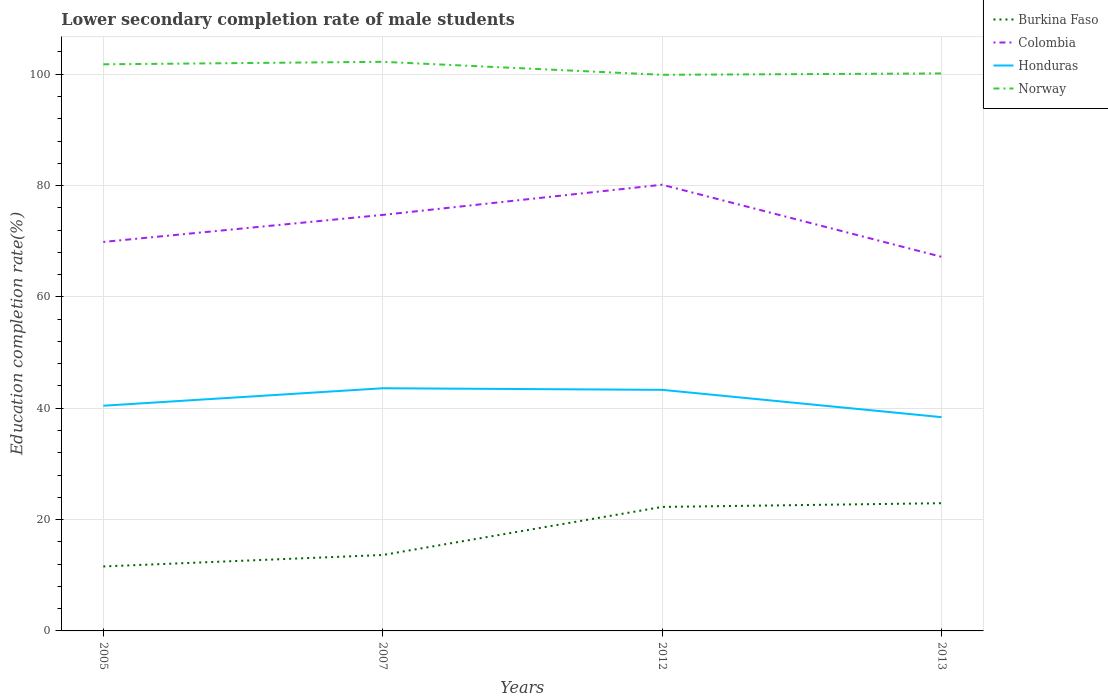Is the number of lines equal to the number of legend labels?
Offer a very short reply. Yes. Across all years, what is the maximum lower secondary completion rate of male students in Honduras?
Give a very brief answer. 38.4. What is the total lower secondary completion rate of male students in Burkina Faso in the graph?
Provide a short and direct response. -11.36. What is the difference between the highest and the second highest lower secondary completion rate of male students in Colombia?
Provide a succinct answer. 12.95. Are the values on the major ticks of Y-axis written in scientific E-notation?
Make the answer very short. No. Does the graph contain any zero values?
Ensure brevity in your answer.  No. Does the graph contain grids?
Your response must be concise. Yes. How many legend labels are there?
Give a very brief answer. 4. How are the legend labels stacked?
Your response must be concise. Vertical. What is the title of the graph?
Provide a succinct answer. Lower secondary completion rate of male students. What is the label or title of the X-axis?
Your response must be concise. Years. What is the label or title of the Y-axis?
Provide a succinct answer. Education completion rate(%). What is the Education completion rate(%) in Burkina Faso in 2005?
Make the answer very short. 11.58. What is the Education completion rate(%) in Colombia in 2005?
Give a very brief answer. 69.87. What is the Education completion rate(%) of Honduras in 2005?
Keep it short and to the point. 40.45. What is the Education completion rate(%) in Norway in 2005?
Your response must be concise. 101.78. What is the Education completion rate(%) of Burkina Faso in 2007?
Keep it short and to the point. 13.64. What is the Education completion rate(%) of Colombia in 2007?
Make the answer very short. 74.73. What is the Education completion rate(%) of Honduras in 2007?
Give a very brief answer. 43.59. What is the Education completion rate(%) in Norway in 2007?
Give a very brief answer. 102.23. What is the Education completion rate(%) in Burkina Faso in 2012?
Offer a very short reply. 22.27. What is the Education completion rate(%) in Colombia in 2012?
Keep it short and to the point. 80.15. What is the Education completion rate(%) of Honduras in 2012?
Keep it short and to the point. 43.3. What is the Education completion rate(%) of Norway in 2012?
Provide a short and direct response. 99.89. What is the Education completion rate(%) of Burkina Faso in 2013?
Keep it short and to the point. 22.94. What is the Education completion rate(%) of Colombia in 2013?
Offer a terse response. 67.2. What is the Education completion rate(%) in Honduras in 2013?
Offer a terse response. 38.4. What is the Education completion rate(%) in Norway in 2013?
Offer a terse response. 100.14. Across all years, what is the maximum Education completion rate(%) in Burkina Faso?
Your answer should be very brief. 22.94. Across all years, what is the maximum Education completion rate(%) of Colombia?
Offer a very short reply. 80.15. Across all years, what is the maximum Education completion rate(%) in Honduras?
Give a very brief answer. 43.59. Across all years, what is the maximum Education completion rate(%) of Norway?
Your answer should be compact. 102.23. Across all years, what is the minimum Education completion rate(%) of Burkina Faso?
Offer a very short reply. 11.58. Across all years, what is the minimum Education completion rate(%) in Colombia?
Offer a terse response. 67.2. Across all years, what is the minimum Education completion rate(%) of Honduras?
Your response must be concise. 38.4. Across all years, what is the minimum Education completion rate(%) of Norway?
Provide a succinct answer. 99.89. What is the total Education completion rate(%) in Burkina Faso in the graph?
Ensure brevity in your answer.  70.43. What is the total Education completion rate(%) in Colombia in the graph?
Your answer should be compact. 291.94. What is the total Education completion rate(%) in Honduras in the graph?
Your answer should be compact. 165.74. What is the total Education completion rate(%) of Norway in the graph?
Your response must be concise. 404.03. What is the difference between the Education completion rate(%) in Burkina Faso in 2005 and that in 2007?
Your answer should be very brief. -2.06. What is the difference between the Education completion rate(%) in Colombia in 2005 and that in 2007?
Keep it short and to the point. -4.85. What is the difference between the Education completion rate(%) of Honduras in 2005 and that in 2007?
Offer a very short reply. -3.14. What is the difference between the Education completion rate(%) of Norway in 2005 and that in 2007?
Your answer should be compact. -0.45. What is the difference between the Education completion rate(%) of Burkina Faso in 2005 and that in 2012?
Keep it short and to the point. -10.69. What is the difference between the Education completion rate(%) of Colombia in 2005 and that in 2012?
Your response must be concise. -10.28. What is the difference between the Education completion rate(%) of Honduras in 2005 and that in 2012?
Your answer should be compact. -2.85. What is the difference between the Education completion rate(%) in Norway in 2005 and that in 2012?
Your answer should be very brief. 1.88. What is the difference between the Education completion rate(%) in Burkina Faso in 2005 and that in 2013?
Keep it short and to the point. -11.36. What is the difference between the Education completion rate(%) of Colombia in 2005 and that in 2013?
Make the answer very short. 2.67. What is the difference between the Education completion rate(%) of Honduras in 2005 and that in 2013?
Offer a terse response. 2.05. What is the difference between the Education completion rate(%) in Norway in 2005 and that in 2013?
Make the answer very short. 1.64. What is the difference between the Education completion rate(%) in Burkina Faso in 2007 and that in 2012?
Give a very brief answer. -8.64. What is the difference between the Education completion rate(%) of Colombia in 2007 and that in 2012?
Give a very brief answer. -5.42. What is the difference between the Education completion rate(%) in Honduras in 2007 and that in 2012?
Ensure brevity in your answer.  0.28. What is the difference between the Education completion rate(%) of Norway in 2007 and that in 2012?
Provide a short and direct response. 2.33. What is the difference between the Education completion rate(%) of Burkina Faso in 2007 and that in 2013?
Make the answer very short. -9.3. What is the difference between the Education completion rate(%) of Colombia in 2007 and that in 2013?
Ensure brevity in your answer.  7.53. What is the difference between the Education completion rate(%) of Honduras in 2007 and that in 2013?
Ensure brevity in your answer.  5.19. What is the difference between the Education completion rate(%) in Norway in 2007 and that in 2013?
Ensure brevity in your answer.  2.09. What is the difference between the Education completion rate(%) in Burkina Faso in 2012 and that in 2013?
Your answer should be compact. -0.67. What is the difference between the Education completion rate(%) of Colombia in 2012 and that in 2013?
Your response must be concise. 12.95. What is the difference between the Education completion rate(%) of Honduras in 2012 and that in 2013?
Offer a very short reply. 4.91. What is the difference between the Education completion rate(%) of Norway in 2012 and that in 2013?
Ensure brevity in your answer.  -0.25. What is the difference between the Education completion rate(%) in Burkina Faso in 2005 and the Education completion rate(%) in Colombia in 2007?
Give a very brief answer. -63.14. What is the difference between the Education completion rate(%) of Burkina Faso in 2005 and the Education completion rate(%) of Honduras in 2007?
Provide a short and direct response. -32.01. What is the difference between the Education completion rate(%) of Burkina Faso in 2005 and the Education completion rate(%) of Norway in 2007?
Provide a short and direct response. -90.65. What is the difference between the Education completion rate(%) in Colombia in 2005 and the Education completion rate(%) in Honduras in 2007?
Your answer should be very brief. 26.28. What is the difference between the Education completion rate(%) in Colombia in 2005 and the Education completion rate(%) in Norway in 2007?
Ensure brevity in your answer.  -32.36. What is the difference between the Education completion rate(%) in Honduras in 2005 and the Education completion rate(%) in Norway in 2007?
Ensure brevity in your answer.  -61.78. What is the difference between the Education completion rate(%) of Burkina Faso in 2005 and the Education completion rate(%) of Colombia in 2012?
Give a very brief answer. -68.57. What is the difference between the Education completion rate(%) in Burkina Faso in 2005 and the Education completion rate(%) in Honduras in 2012?
Provide a succinct answer. -31.72. What is the difference between the Education completion rate(%) of Burkina Faso in 2005 and the Education completion rate(%) of Norway in 2012?
Your response must be concise. -88.31. What is the difference between the Education completion rate(%) of Colombia in 2005 and the Education completion rate(%) of Honduras in 2012?
Provide a short and direct response. 26.57. What is the difference between the Education completion rate(%) in Colombia in 2005 and the Education completion rate(%) in Norway in 2012?
Keep it short and to the point. -30.02. What is the difference between the Education completion rate(%) in Honduras in 2005 and the Education completion rate(%) in Norway in 2012?
Your answer should be very brief. -59.44. What is the difference between the Education completion rate(%) in Burkina Faso in 2005 and the Education completion rate(%) in Colombia in 2013?
Your answer should be compact. -55.62. What is the difference between the Education completion rate(%) of Burkina Faso in 2005 and the Education completion rate(%) of Honduras in 2013?
Provide a succinct answer. -26.82. What is the difference between the Education completion rate(%) of Burkina Faso in 2005 and the Education completion rate(%) of Norway in 2013?
Offer a terse response. -88.56. What is the difference between the Education completion rate(%) in Colombia in 2005 and the Education completion rate(%) in Honduras in 2013?
Give a very brief answer. 31.47. What is the difference between the Education completion rate(%) of Colombia in 2005 and the Education completion rate(%) of Norway in 2013?
Ensure brevity in your answer.  -30.27. What is the difference between the Education completion rate(%) of Honduras in 2005 and the Education completion rate(%) of Norway in 2013?
Make the answer very short. -59.69. What is the difference between the Education completion rate(%) in Burkina Faso in 2007 and the Education completion rate(%) in Colombia in 2012?
Provide a short and direct response. -66.51. What is the difference between the Education completion rate(%) in Burkina Faso in 2007 and the Education completion rate(%) in Honduras in 2012?
Make the answer very short. -29.67. What is the difference between the Education completion rate(%) of Burkina Faso in 2007 and the Education completion rate(%) of Norway in 2012?
Offer a terse response. -86.25. What is the difference between the Education completion rate(%) in Colombia in 2007 and the Education completion rate(%) in Honduras in 2012?
Offer a very short reply. 31.42. What is the difference between the Education completion rate(%) in Colombia in 2007 and the Education completion rate(%) in Norway in 2012?
Your answer should be compact. -25.17. What is the difference between the Education completion rate(%) in Honduras in 2007 and the Education completion rate(%) in Norway in 2012?
Your answer should be compact. -56.3. What is the difference between the Education completion rate(%) in Burkina Faso in 2007 and the Education completion rate(%) in Colombia in 2013?
Give a very brief answer. -53.56. What is the difference between the Education completion rate(%) in Burkina Faso in 2007 and the Education completion rate(%) in Honduras in 2013?
Make the answer very short. -24.76. What is the difference between the Education completion rate(%) of Burkina Faso in 2007 and the Education completion rate(%) of Norway in 2013?
Provide a succinct answer. -86.5. What is the difference between the Education completion rate(%) in Colombia in 2007 and the Education completion rate(%) in Honduras in 2013?
Offer a terse response. 36.33. What is the difference between the Education completion rate(%) in Colombia in 2007 and the Education completion rate(%) in Norway in 2013?
Provide a succinct answer. -25.41. What is the difference between the Education completion rate(%) in Honduras in 2007 and the Education completion rate(%) in Norway in 2013?
Your answer should be compact. -56.55. What is the difference between the Education completion rate(%) in Burkina Faso in 2012 and the Education completion rate(%) in Colombia in 2013?
Offer a very short reply. -44.92. What is the difference between the Education completion rate(%) of Burkina Faso in 2012 and the Education completion rate(%) of Honduras in 2013?
Provide a short and direct response. -16.12. What is the difference between the Education completion rate(%) in Burkina Faso in 2012 and the Education completion rate(%) in Norway in 2013?
Keep it short and to the point. -77.86. What is the difference between the Education completion rate(%) in Colombia in 2012 and the Education completion rate(%) in Honduras in 2013?
Your answer should be very brief. 41.75. What is the difference between the Education completion rate(%) in Colombia in 2012 and the Education completion rate(%) in Norway in 2013?
Offer a very short reply. -19.99. What is the difference between the Education completion rate(%) in Honduras in 2012 and the Education completion rate(%) in Norway in 2013?
Ensure brevity in your answer.  -56.83. What is the average Education completion rate(%) in Burkina Faso per year?
Provide a succinct answer. 17.61. What is the average Education completion rate(%) in Colombia per year?
Provide a short and direct response. 72.99. What is the average Education completion rate(%) in Honduras per year?
Provide a succinct answer. 41.44. What is the average Education completion rate(%) in Norway per year?
Offer a very short reply. 101.01. In the year 2005, what is the difference between the Education completion rate(%) of Burkina Faso and Education completion rate(%) of Colombia?
Offer a terse response. -58.29. In the year 2005, what is the difference between the Education completion rate(%) in Burkina Faso and Education completion rate(%) in Honduras?
Keep it short and to the point. -28.87. In the year 2005, what is the difference between the Education completion rate(%) of Burkina Faso and Education completion rate(%) of Norway?
Keep it short and to the point. -90.2. In the year 2005, what is the difference between the Education completion rate(%) in Colombia and Education completion rate(%) in Honduras?
Your answer should be very brief. 29.42. In the year 2005, what is the difference between the Education completion rate(%) of Colombia and Education completion rate(%) of Norway?
Your answer should be very brief. -31.9. In the year 2005, what is the difference between the Education completion rate(%) of Honduras and Education completion rate(%) of Norway?
Provide a succinct answer. -61.33. In the year 2007, what is the difference between the Education completion rate(%) of Burkina Faso and Education completion rate(%) of Colombia?
Your answer should be very brief. -61.09. In the year 2007, what is the difference between the Education completion rate(%) of Burkina Faso and Education completion rate(%) of Honduras?
Offer a very short reply. -29.95. In the year 2007, what is the difference between the Education completion rate(%) of Burkina Faso and Education completion rate(%) of Norway?
Give a very brief answer. -88.59. In the year 2007, what is the difference between the Education completion rate(%) in Colombia and Education completion rate(%) in Honduras?
Provide a short and direct response. 31.14. In the year 2007, what is the difference between the Education completion rate(%) in Colombia and Education completion rate(%) in Norway?
Keep it short and to the point. -27.5. In the year 2007, what is the difference between the Education completion rate(%) of Honduras and Education completion rate(%) of Norway?
Provide a short and direct response. -58.64. In the year 2012, what is the difference between the Education completion rate(%) of Burkina Faso and Education completion rate(%) of Colombia?
Provide a succinct answer. -57.87. In the year 2012, what is the difference between the Education completion rate(%) in Burkina Faso and Education completion rate(%) in Honduras?
Give a very brief answer. -21.03. In the year 2012, what is the difference between the Education completion rate(%) of Burkina Faso and Education completion rate(%) of Norway?
Your answer should be very brief. -77.62. In the year 2012, what is the difference between the Education completion rate(%) in Colombia and Education completion rate(%) in Honduras?
Offer a terse response. 36.84. In the year 2012, what is the difference between the Education completion rate(%) of Colombia and Education completion rate(%) of Norway?
Make the answer very short. -19.74. In the year 2012, what is the difference between the Education completion rate(%) of Honduras and Education completion rate(%) of Norway?
Provide a succinct answer. -56.59. In the year 2013, what is the difference between the Education completion rate(%) in Burkina Faso and Education completion rate(%) in Colombia?
Keep it short and to the point. -44.26. In the year 2013, what is the difference between the Education completion rate(%) in Burkina Faso and Education completion rate(%) in Honduras?
Make the answer very short. -15.46. In the year 2013, what is the difference between the Education completion rate(%) in Burkina Faso and Education completion rate(%) in Norway?
Your response must be concise. -77.2. In the year 2013, what is the difference between the Education completion rate(%) in Colombia and Education completion rate(%) in Honduras?
Offer a terse response. 28.8. In the year 2013, what is the difference between the Education completion rate(%) in Colombia and Education completion rate(%) in Norway?
Give a very brief answer. -32.94. In the year 2013, what is the difference between the Education completion rate(%) of Honduras and Education completion rate(%) of Norway?
Provide a succinct answer. -61.74. What is the ratio of the Education completion rate(%) of Burkina Faso in 2005 to that in 2007?
Make the answer very short. 0.85. What is the ratio of the Education completion rate(%) of Colombia in 2005 to that in 2007?
Keep it short and to the point. 0.94. What is the ratio of the Education completion rate(%) of Honduras in 2005 to that in 2007?
Your answer should be very brief. 0.93. What is the ratio of the Education completion rate(%) of Burkina Faso in 2005 to that in 2012?
Your answer should be very brief. 0.52. What is the ratio of the Education completion rate(%) of Colombia in 2005 to that in 2012?
Provide a succinct answer. 0.87. What is the ratio of the Education completion rate(%) in Honduras in 2005 to that in 2012?
Ensure brevity in your answer.  0.93. What is the ratio of the Education completion rate(%) in Norway in 2005 to that in 2012?
Offer a very short reply. 1.02. What is the ratio of the Education completion rate(%) of Burkina Faso in 2005 to that in 2013?
Offer a very short reply. 0.5. What is the ratio of the Education completion rate(%) in Colombia in 2005 to that in 2013?
Give a very brief answer. 1.04. What is the ratio of the Education completion rate(%) of Honduras in 2005 to that in 2013?
Offer a terse response. 1.05. What is the ratio of the Education completion rate(%) in Norway in 2005 to that in 2013?
Your answer should be very brief. 1.02. What is the ratio of the Education completion rate(%) of Burkina Faso in 2007 to that in 2012?
Your response must be concise. 0.61. What is the ratio of the Education completion rate(%) in Colombia in 2007 to that in 2012?
Your response must be concise. 0.93. What is the ratio of the Education completion rate(%) of Norway in 2007 to that in 2012?
Provide a succinct answer. 1.02. What is the ratio of the Education completion rate(%) of Burkina Faso in 2007 to that in 2013?
Offer a very short reply. 0.59. What is the ratio of the Education completion rate(%) of Colombia in 2007 to that in 2013?
Provide a short and direct response. 1.11. What is the ratio of the Education completion rate(%) of Honduras in 2007 to that in 2013?
Offer a very short reply. 1.14. What is the ratio of the Education completion rate(%) in Norway in 2007 to that in 2013?
Provide a succinct answer. 1.02. What is the ratio of the Education completion rate(%) of Burkina Faso in 2012 to that in 2013?
Your answer should be very brief. 0.97. What is the ratio of the Education completion rate(%) of Colombia in 2012 to that in 2013?
Keep it short and to the point. 1.19. What is the ratio of the Education completion rate(%) of Honduras in 2012 to that in 2013?
Keep it short and to the point. 1.13. What is the ratio of the Education completion rate(%) in Norway in 2012 to that in 2013?
Ensure brevity in your answer.  1. What is the difference between the highest and the second highest Education completion rate(%) of Burkina Faso?
Offer a terse response. 0.67. What is the difference between the highest and the second highest Education completion rate(%) in Colombia?
Provide a short and direct response. 5.42. What is the difference between the highest and the second highest Education completion rate(%) of Honduras?
Offer a terse response. 0.28. What is the difference between the highest and the second highest Education completion rate(%) in Norway?
Provide a succinct answer. 0.45. What is the difference between the highest and the lowest Education completion rate(%) in Burkina Faso?
Your answer should be very brief. 11.36. What is the difference between the highest and the lowest Education completion rate(%) in Colombia?
Keep it short and to the point. 12.95. What is the difference between the highest and the lowest Education completion rate(%) in Honduras?
Provide a short and direct response. 5.19. What is the difference between the highest and the lowest Education completion rate(%) of Norway?
Offer a terse response. 2.33. 